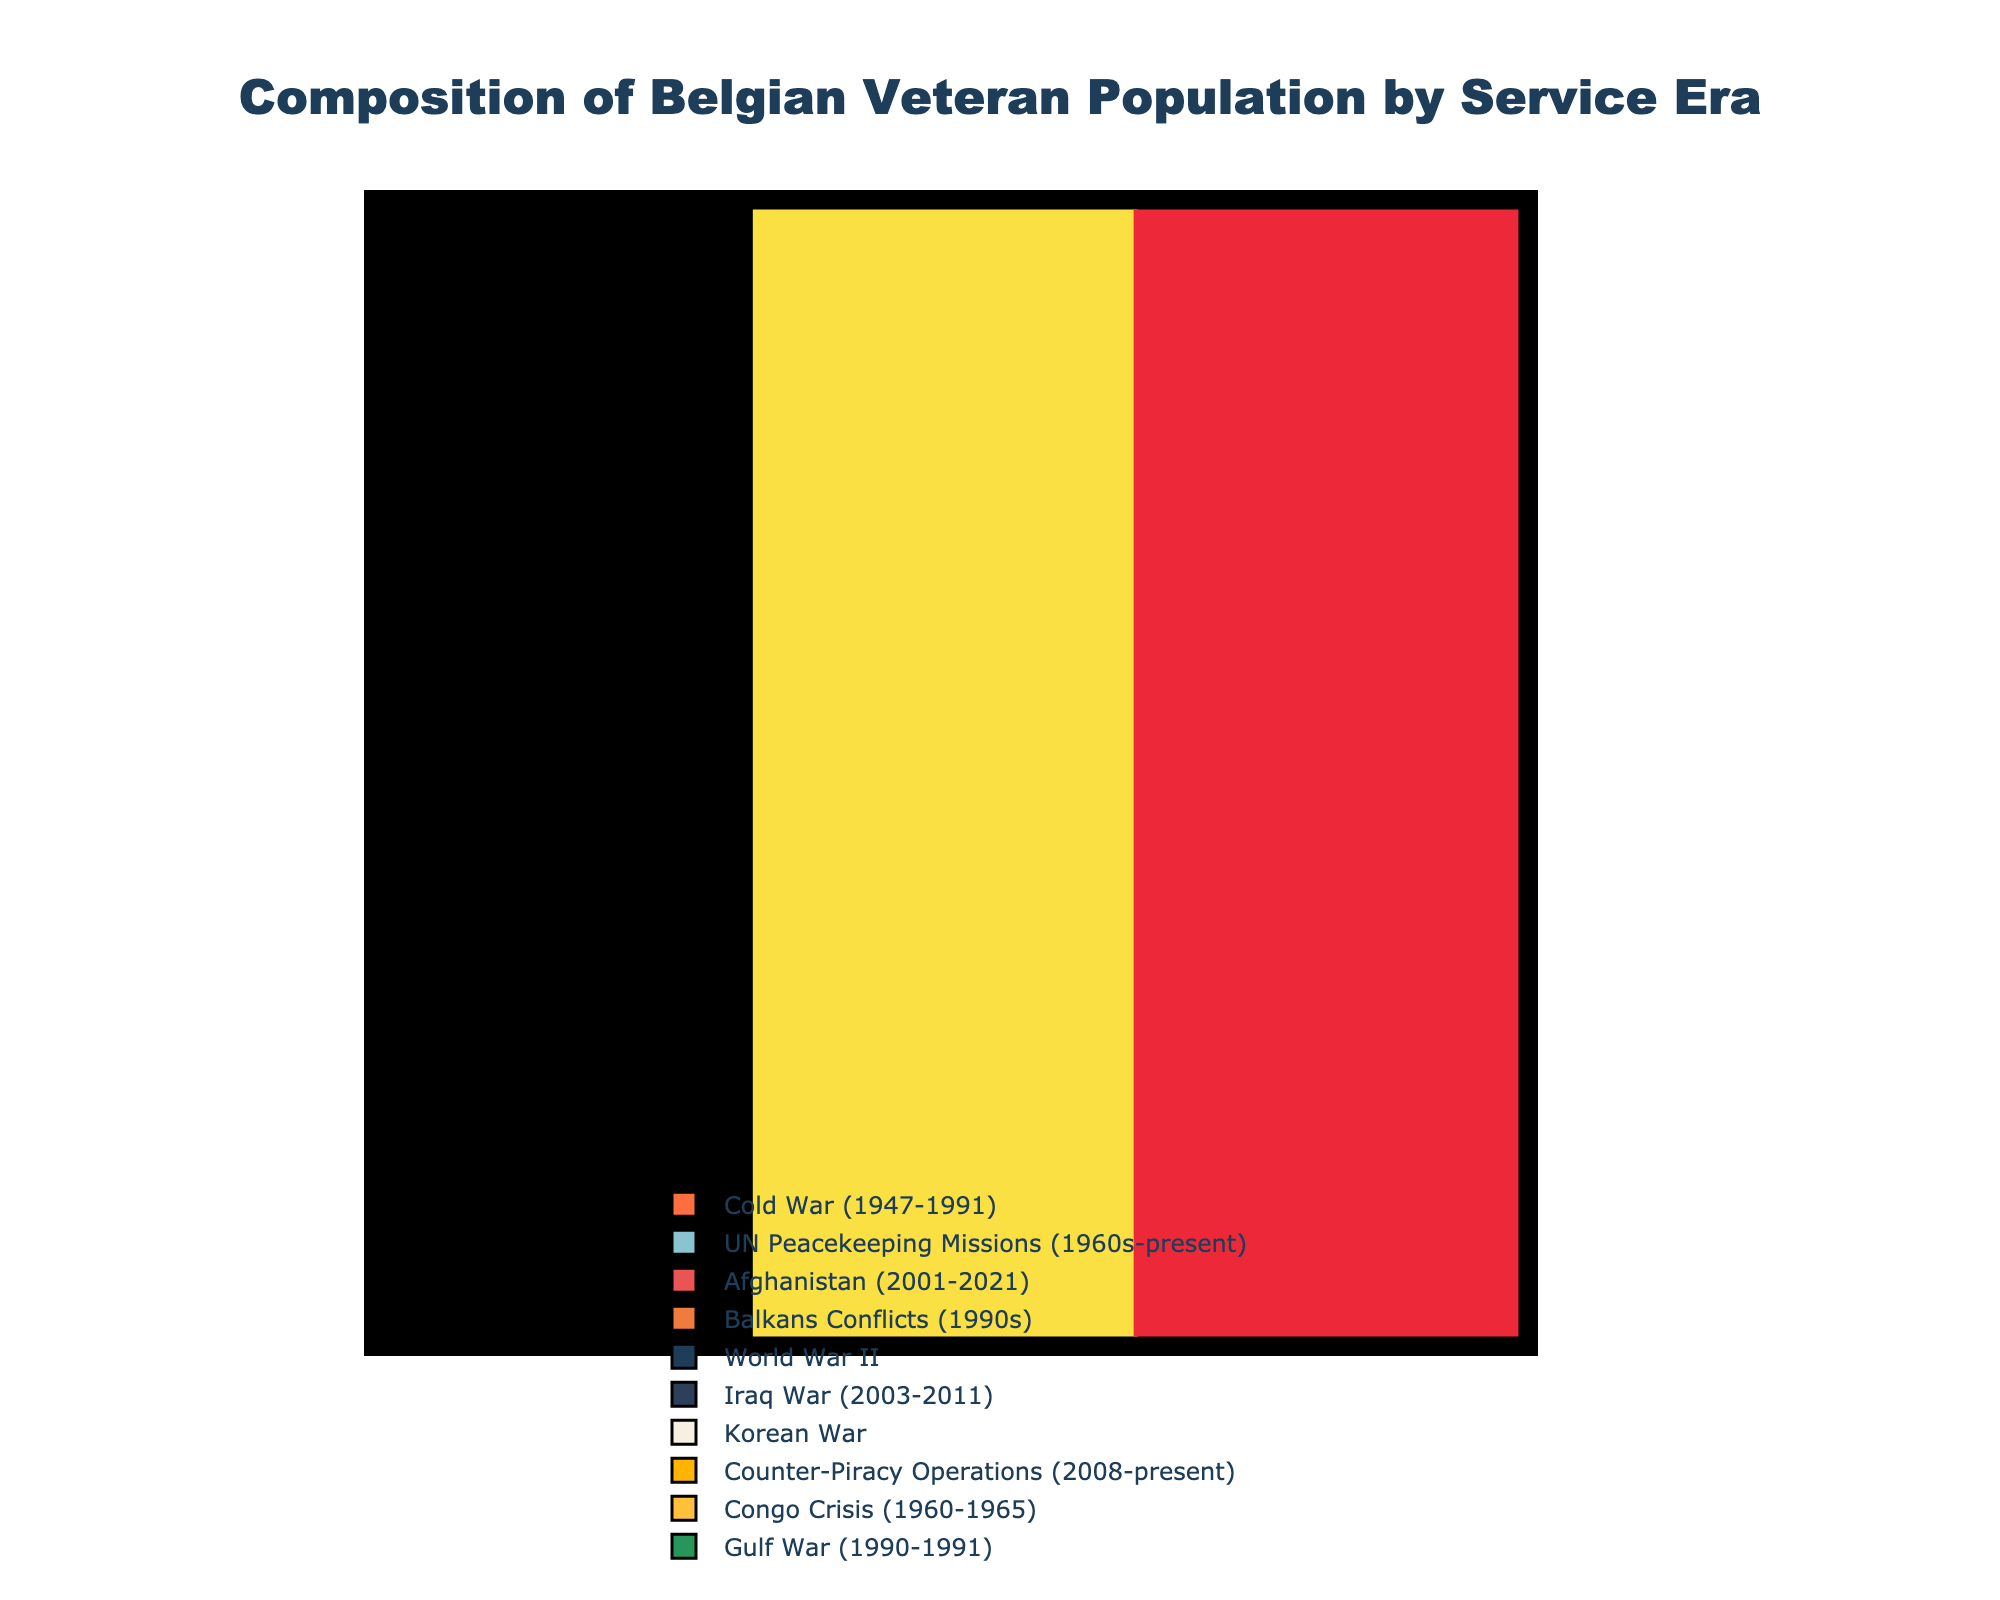What's the combined percentage of veterans from the Cold War and UN Peacekeeping Missions? Sum the percentages of the Cold War (28.5) and UN Peacekeeping Missions (22.7). The combined percentage is 28.5 + 22.7 = 51.2
Answer: 51.2 Which service era has the lowest percentage of veterans? Identify the service era with the smallest percentage by comparing all given values. The Congo Crisis has the lowest percentage at 2.1%
Answer: Congo Crisis Are there more veterans from Afghanistan or Balkans Conflicts? Compare the percentages of veterans from Afghanistan (15.6) and Balkans Conflicts (12.4). Afghanistan has a higher percentage.
Answer: Afghanistan What is the percentage difference between World War II and the Iraq War veterans? Subtract the percentage of Iraq War veterans (4.8) from the percentage of World War II veterans (5.2). The difference is 5.2 - 4.8 = 0.4
Answer: 0.4 What is the sum of the percentages for veterans from the Gulf War, Korean War, and Counter-Piracy Operations? Add the percentages of the Gulf War (1.9), Korean War (3.8), and Counter-Piracy Operations (3.0). The combined sum is 1.9 + 3.8 + 3.0 = 8.7
Answer: 8.7 Which service era corresponds to the blue segment in the pie chart? Identify the segment colored blue and refer to its corresponding label. The Cold War era is associated with the blue segment.
Answer: Cold War Which two service eras have percentages that add up to roughly 26%? Search for percentages that sum up near 26%. The Balkans Conflicts (12.4) and Afghanistan (15.6) together equal 12.4 + 15.6 = 28
Answer: Balkans Conflicts and Afghanistan Do veterans from the Korean War era outnumber those from Counter-Piracy Operations? Compare the percentages of the Korean War (3.8) to Counter-Piracy Operations (3.0). Korean War veterans are more.
Answer: Yes Is the percentage of veterans from World War II higher than that from the Congo Crisis and Gulf War combined? Compare the percentage of World War II veterans (5.2) with the combined percentage of Congo Crisis (2.1) and Gulf War (1.9). The combined percentage is 2.1 + 1.9 = 4.0, which is less than 5.2.
Answer: Yes 